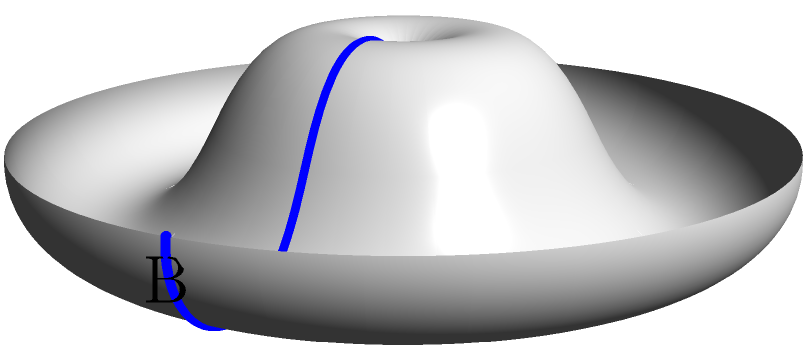As a UX/UI collaborator, you're tasked with mapping a Möbius strip for a quirky design project. If you start at point A and traverse the strip, ending at point B, how many complete rotations will you make before reaching the opposite side of your starting point? Express your answer in terms of $\pi$. Let's break this down step-by-step:

1) A Möbius strip is a non-orientable surface with only one side and one edge.

2) To understand the rotations, we need to consider the twist in the strip:
   - A standard Möbius strip has a half-twist (180°) built into it.

3) As we traverse the strip from A to B:
   - We make one complete circuit around the strip.
   - During this circuit, we rotate by 180° (or $\pi$ radians) due to the half-twist.

4) To reach the opposite side of our starting point:
   - We need to rotate by another 180° (or $\pi$ radians).

5) Total rotation to reach the opposite side:
   $180° + 180° = 360°$ or $\pi + \pi = 2\pi$ radians

6) Therefore, we make one complete rotation ($2\pi$ radians) before reaching the opposite side of our starting point.
Answer: $1$ (or $2\pi$ radians) 